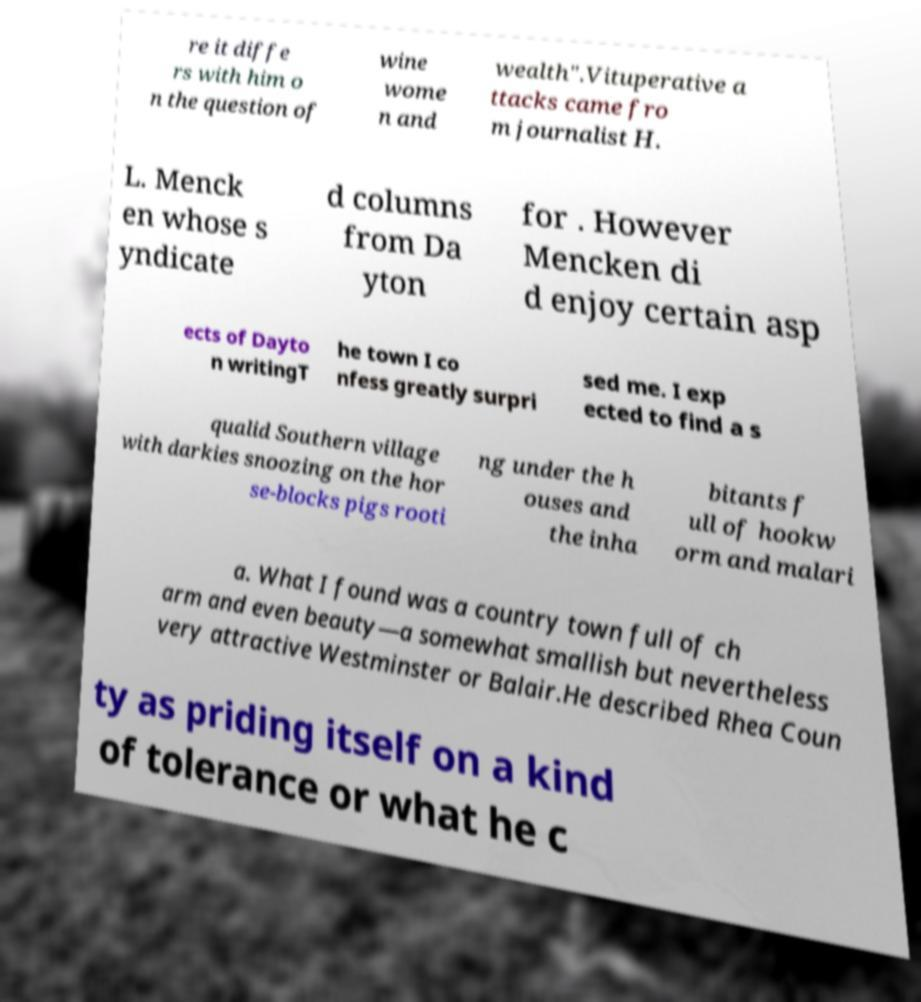Can you read and provide the text displayed in the image?This photo seems to have some interesting text. Can you extract and type it out for me? re it diffe rs with him o n the question of wine wome n and wealth".Vituperative a ttacks came fro m journalist H. L. Menck en whose s yndicate d columns from Da yton for . However Mencken di d enjoy certain asp ects of Dayto n writingT he town I co nfess greatly surpri sed me. I exp ected to find a s qualid Southern village with darkies snoozing on the hor se-blocks pigs rooti ng under the h ouses and the inha bitants f ull of hookw orm and malari a. What I found was a country town full of ch arm and even beauty—a somewhat smallish but nevertheless very attractive Westminster or Balair.He described Rhea Coun ty as priding itself on a kind of tolerance or what he c 